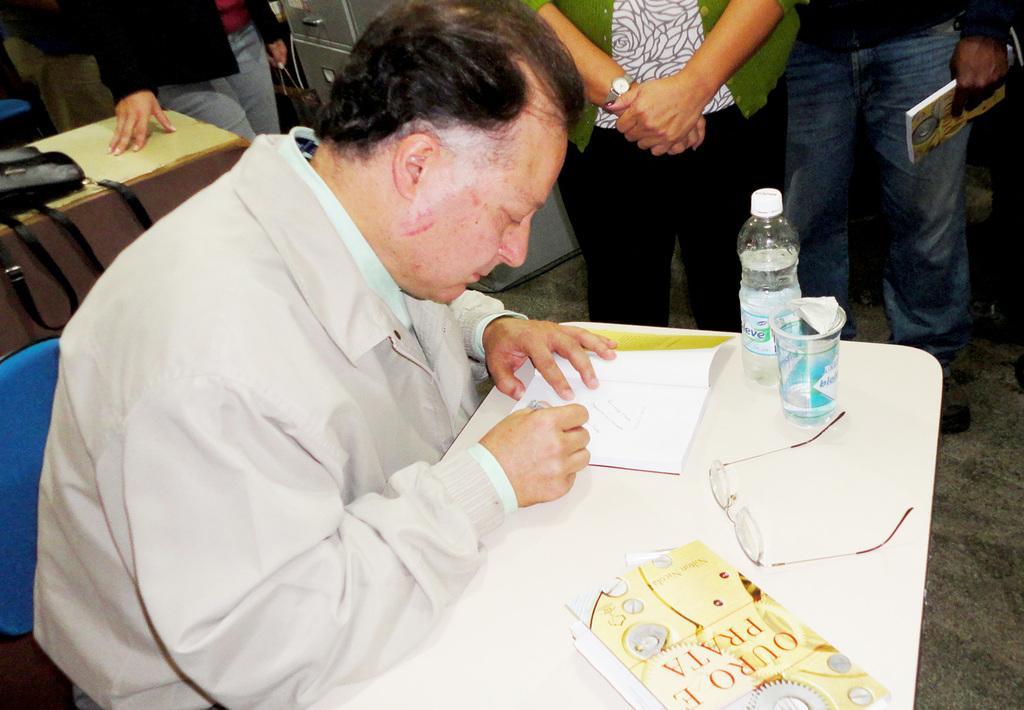How would you summarize this image in a sentence or two? In this picture we can see a man sitting on a chair and doing some work. In front of the man there is a table and on the table there are books, spectacles, glass and a bottle. Behind the man there are a group of people standing and a person is holding a book. On the left side of the man there is a black bag on the other table. 